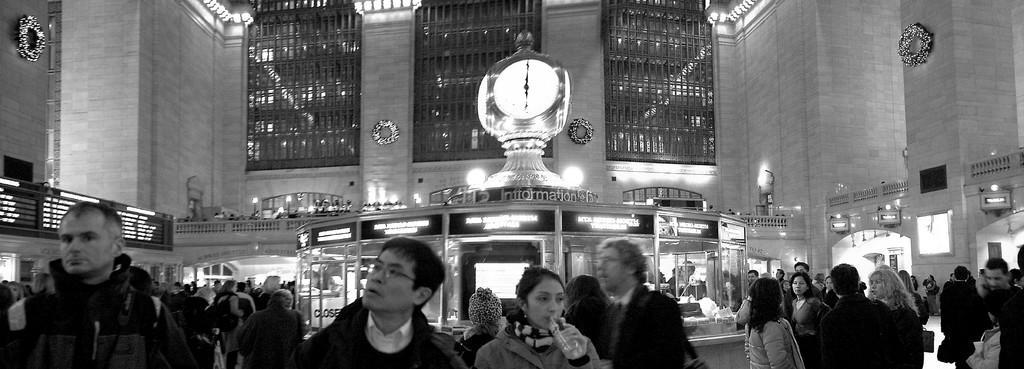Can you describe this image briefly? In this image, we can see a building with walls, decorative items, grills, light and railings. At the bottom of the image, we can see a group of people. Here a woman is holding a bottle, digital screens, clock and banner. 